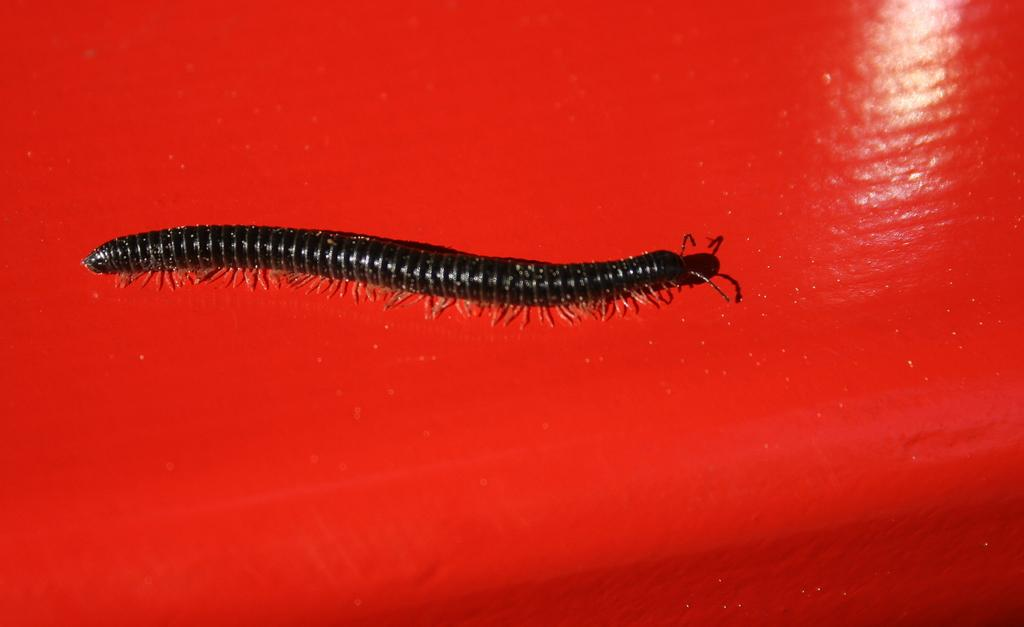What is the main subject of the image? The main subject of the image is a worm. Where is the worm located in the image? The worm is on a table in the image. What type of home does the worm live in on the table? There is no indication of a home for the worm in the image, as it is simply on the table. What type of rifle is the worm holding in the image? There is no rifle present in the image; it only features a worm on a table. 